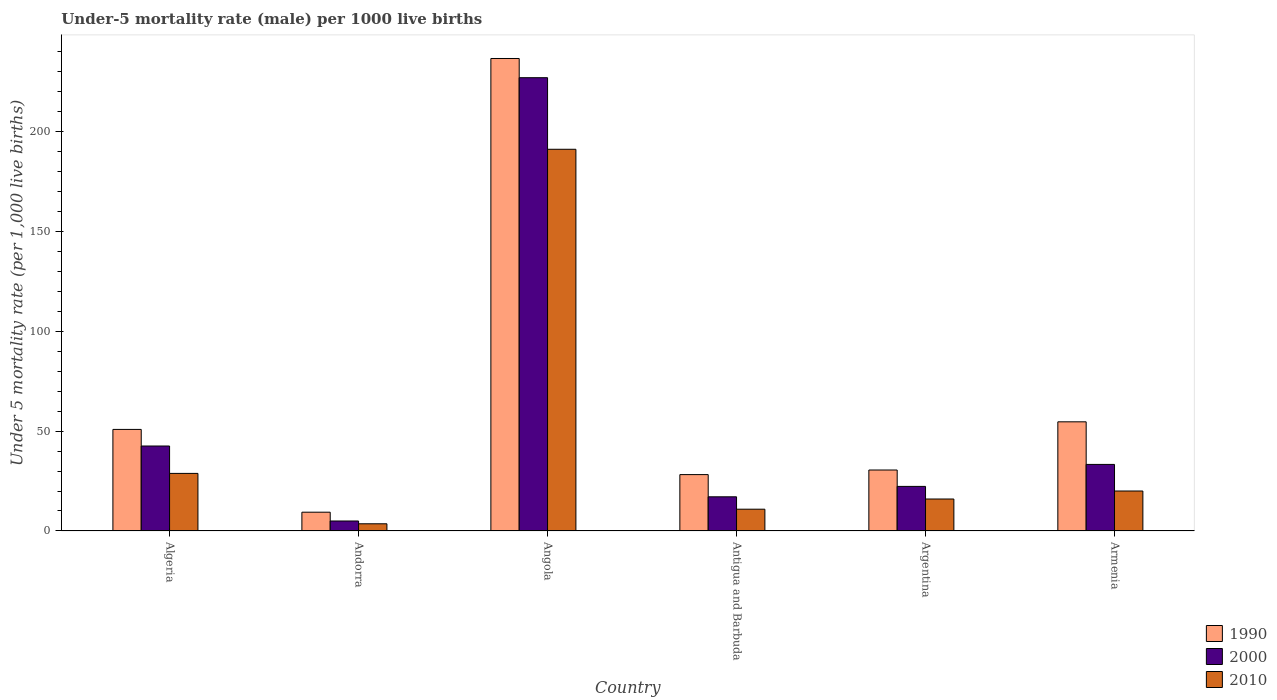How many groups of bars are there?
Provide a succinct answer. 6. Are the number of bars on each tick of the X-axis equal?
Keep it short and to the point. Yes. What is the label of the 1st group of bars from the left?
Ensure brevity in your answer.  Algeria. In how many cases, is the number of bars for a given country not equal to the number of legend labels?
Your answer should be compact. 0. What is the under-five mortality rate in 1990 in Andorra?
Offer a very short reply. 9.4. Across all countries, what is the maximum under-five mortality rate in 1990?
Your response must be concise. 236.3. Across all countries, what is the minimum under-five mortality rate in 2000?
Provide a succinct answer. 5. In which country was the under-five mortality rate in 1990 maximum?
Your response must be concise. Angola. In which country was the under-five mortality rate in 1990 minimum?
Your answer should be compact. Andorra. What is the total under-five mortality rate in 1990 in the graph?
Offer a terse response. 409.8. What is the difference between the under-five mortality rate in 1990 in Algeria and that in Argentina?
Your answer should be very brief. 20.3. What is the difference between the under-five mortality rate in 1990 in Algeria and the under-five mortality rate in 2010 in Andorra?
Ensure brevity in your answer.  47.2. What is the average under-five mortality rate in 2000 per country?
Your answer should be very brief. 57.82. In how many countries, is the under-five mortality rate in 1990 greater than 160?
Provide a short and direct response. 1. What is the ratio of the under-five mortality rate in 2010 in Algeria to that in Angola?
Provide a succinct answer. 0.15. What is the difference between the highest and the second highest under-five mortality rate in 2000?
Provide a succinct answer. -193.4. What is the difference between the highest and the lowest under-five mortality rate in 1990?
Keep it short and to the point. 226.9. Is the sum of the under-five mortality rate in 1990 in Angola and Argentina greater than the maximum under-five mortality rate in 2000 across all countries?
Offer a terse response. Yes. What does the 1st bar from the left in Antigua and Barbuda represents?
Your answer should be very brief. 1990. What does the 1st bar from the right in Andorra represents?
Your answer should be very brief. 2010. How many bars are there?
Offer a terse response. 18. Are all the bars in the graph horizontal?
Keep it short and to the point. No. What is the difference between two consecutive major ticks on the Y-axis?
Offer a very short reply. 50. Are the values on the major ticks of Y-axis written in scientific E-notation?
Provide a short and direct response. No. Does the graph contain grids?
Your response must be concise. No. Where does the legend appear in the graph?
Offer a terse response. Bottom right. How are the legend labels stacked?
Keep it short and to the point. Vertical. What is the title of the graph?
Offer a very short reply. Under-5 mortality rate (male) per 1000 live births. What is the label or title of the Y-axis?
Provide a succinct answer. Under 5 mortality rate (per 1,0 live births). What is the Under 5 mortality rate (per 1,000 live births) of 1990 in Algeria?
Offer a terse response. 50.8. What is the Under 5 mortality rate (per 1,000 live births) of 2000 in Algeria?
Provide a succinct answer. 42.5. What is the Under 5 mortality rate (per 1,000 live births) in 2010 in Algeria?
Ensure brevity in your answer.  28.8. What is the Under 5 mortality rate (per 1,000 live births) in 1990 in Andorra?
Your answer should be very brief. 9.4. What is the Under 5 mortality rate (per 1,000 live births) in 2000 in Andorra?
Offer a very short reply. 5. What is the Under 5 mortality rate (per 1,000 live births) of 1990 in Angola?
Your response must be concise. 236.3. What is the Under 5 mortality rate (per 1,000 live births) in 2000 in Angola?
Keep it short and to the point. 226.7. What is the Under 5 mortality rate (per 1,000 live births) in 2010 in Angola?
Make the answer very short. 190.9. What is the Under 5 mortality rate (per 1,000 live births) of 1990 in Antigua and Barbuda?
Give a very brief answer. 28.2. What is the Under 5 mortality rate (per 1,000 live births) of 2010 in Antigua and Barbuda?
Your answer should be very brief. 10.9. What is the Under 5 mortality rate (per 1,000 live births) of 1990 in Argentina?
Keep it short and to the point. 30.5. What is the Under 5 mortality rate (per 1,000 live births) in 2000 in Argentina?
Offer a terse response. 22.3. What is the Under 5 mortality rate (per 1,000 live births) of 1990 in Armenia?
Offer a terse response. 54.6. What is the Under 5 mortality rate (per 1,000 live births) in 2000 in Armenia?
Keep it short and to the point. 33.3. What is the Under 5 mortality rate (per 1,000 live births) in 2010 in Armenia?
Your response must be concise. 20. Across all countries, what is the maximum Under 5 mortality rate (per 1,000 live births) in 1990?
Your answer should be compact. 236.3. Across all countries, what is the maximum Under 5 mortality rate (per 1,000 live births) of 2000?
Your answer should be compact. 226.7. Across all countries, what is the maximum Under 5 mortality rate (per 1,000 live births) of 2010?
Offer a very short reply. 190.9. Across all countries, what is the minimum Under 5 mortality rate (per 1,000 live births) in 1990?
Ensure brevity in your answer.  9.4. What is the total Under 5 mortality rate (per 1,000 live births) in 1990 in the graph?
Ensure brevity in your answer.  409.8. What is the total Under 5 mortality rate (per 1,000 live births) in 2000 in the graph?
Ensure brevity in your answer.  346.9. What is the total Under 5 mortality rate (per 1,000 live births) of 2010 in the graph?
Ensure brevity in your answer.  270.2. What is the difference between the Under 5 mortality rate (per 1,000 live births) in 1990 in Algeria and that in Andorra?
Ensure brevity in your answer.  41.4. What is the difference between the Under 5 mortality rate (per 1,000 live births) in 2000 in Algeria and that in Andorra?
Offer a very short reply. 37.5. What is the difference between the Under 5 mortality rate (per 1,000 live births) in 2010 in Algeria and that in Andorra?
Ensure brevity in your answer.  25.2. What is the difference between the Under 5 mortality rate (per 1,000 live births) in 1990 in Algeria and that in Angola?
Your answer should be compact. -185.5. What is the difference between the Under 5 mortality rate (per 1,000 live births) in 2000 in Algeria and that in Angola?
Provide a succinct answer. -184.2. What is the difference between the Under 5 mortality rate (per 1,000 live births) in 2010 in Algeria and that in Angola?
Your answer should be compact. -162.1. What is the difference between the Under 5 mortality rate (per 1,000 live births) in 1990 in Algeria and that in Antigua and Barbuda?
Your answer should be compact. 22.6. What is the difference between the Under 5 mortality rate (per 1,000 live births) of 2000 in Algeria and that in Antigua and Barbuda?
Your answer should be compact. 25.4. What is the difference between the Under 5 mortality rate (per 1,000 live births) in 2010 in Algeria and that in Antigua and Barbuda?
Your answer should be compact. 17.9. What is the difference between the Under 5 mortality rate (per 1,000 live births) of 1990 in Algeria and that in Argentina?
Make the answer very short. 20.3. What is the difference between the Under 5 mortality rate (per 1,000 live births) of 2000 in Algeria and that in Argentina?
Ensure brevity in your answer.  20.2. What is the difference between the Under 5 mortality rate (per 1,000 live births) in 1990 in Algeria and that in Armenia?
Your answer should be compact. -3.8. What is the difference between the Under 5 mortality rate (per 1,000 live births) in 2000 in Algeria and that in Armenia?
Your answer should be very brief. 9.2. What is the difference between the Under 5 mortality rate (per 1,000 live births) in 2010 in Algeria and that in Armenia?
Your response must be concise. 8.8. What is the difference between the Under 5 mortality rate (per 1,000 live births) of 1990 in Andorra and that in Angola?
Provide a succinct answer. -226.9. What is the difference between the Under 5 mortality rate (per 1,000 live births) in 2000 in Andorra and that in Angola?
Ensure brevity in your answer.  -221.7. What is the difference between the Under 5 mortality rate (per 1,000 live births) in 2010 in Andorra and that in Angola?
Your response must be concise. -187.3. What is the difference between the Under 5 mortality rate (per 1,000 live births) in 1990 in Andorra and that in Antigua and Barbuda?
Your answer should be very brief. -18.8. What is the difference between the Under 5 mortality rate (per 1,000 live births) in 1990 in Andorra and that in Argentina?
Provide a succinct answer. -21.1. What is the difference between the Under 5 mortality rate (per 1,000 live births) in 2000 in Andorra and that in Argentina?
Your answer should be very brief. -17.3. What is the difference between the Under 5 mortality rate (per 1,000 live births) in 1990 in Andorra and that in Armenia?
Provide a succinct answer. -45.2. What is the difference between the Under 5 mortality rate (per 1,000 live births) of 2000 in Andorra and that in Armenia?
Offer a very short reply. -28.3. What is the difference between the Under 5 mortality rate (per 1,000 live births) in 2010 in Andorra and that in Armenia?
Make the answer very short. -16.4. What is the difference between the Under 5 mortality rate (per 1,000 live births) of 1990 in Angola and that in Antigua and Barbuda?
Make the answer very short. 208.1. What is the difference between the Under 5 mortality rate (per 1,000 live births) in 2000 in Angola and that in Antigua and Barbuda?
Provide a succinct answer. 209.6. What is the difference between the Under 5 mortality rate (per 1,000 live births) in 2010 in Angola and that in Antigua and Barbuda?
Ensure brevity in your answer.  180. What is the difference between the Under 5 mortality rate (per 1,000 live births) of 1990 in Angola and that in Argentina?
Your response must be concise. 205.8. What is the difference between the Under 5 mortality rate (per 1,000 live births) in 2000 in Angola and that in Argentina?
Offer a very short reply. 204.4. What is the difference between the Under 5 mortality rate (per 1,000 live births) of 2010 in Angola and that in Argentina?
Make the answer very short. 174.9. What is the difference between the Under 5 mortality rate (per 1,000 live births) in 1990 in Angola and that in Armenia?
Offer a terse response. 181.7. What is the difference between the Under 5 mortality rate (per 1,000 live births) of 2000 in Angola and that in Armenia?
Ensure brevity in your answer.  193.4. What is the difference between the Under 5 mortality rate (per 1,000 live births) in 2010 in Angola and that in Armenia?
Provide a succinct answer. 170.9. What is the difference between the Under 5 mortality rate (per 1,000 live births) in 1990 in Antigua and Barbuda and that in Argentina?
Give a very brief answer. -2.3. What is the difference between the Under 5 mortality rate (per 1,000 live births) of 1990 in Antigua and Barbuda and that in Armenia?
Provide a succinct answer. -26.4. What is the difference between the Under 5 mortality rate (per 1,000 live births) in 2000 in Antigua and Barbuda and that in Armenia?
Ensure brevity in your answer.  -16.2. What is the difference between the Under 5 mortality rate (per 1,000 live births) in 2010 in Antigua and Barbuda and that in Armenia?
Your answer should be compact. -9.1. What is the difference between the Under 5 mortality rate (per 1,000 live births) of 1990 in Argentina and that in Armenia?
Provide a succinct answer. -24.1. What is the difference between the Under 5 mortality rate (per 1,000 live births) in 2000 in Argentina and that in Armenia?
Your answer should be very brief. -11. What is the difference between the Under 5 mortality rate (per 1,000 live births) of 1990 in Algeria and the Under 5 mortality rate (per 1,000 live births) of 2000 in Andorra?
Make the answer very short. 45.8. What is the difference between the Under 5 mortality rate (per 1,000 live births) of 1990 in Algeria and the Under 5 mortality rate (per 1,000 live births) of 2010 in Andorra?
Your answer should be very brief. 47.2. What is the difference between the Under 5 mortality rate (per 1,000 live births) of 2000 in Algeria and the Under 5 mortality rate (per 1,000 live births) of 2010 in Andorra?
Offer a terse response. 38.9. What is the difference between the Under 5 mortality rate (per 1,000 live births) in 1990 in Algeria and the Under 5 mortality rate (per 1,000 live births) in 2000 in Angola?
Your answer should be very brief. -175.9. What is the difference between the Under 5 mortality rate (per 1,000 live births) in 1990 in Algeria and the Under 5 mortality rate (per 1,000 live births) in 2010 in Angola?
Offer a terse response. -140.1. What is the difference between the Under 5 mortality rate (per 1,000 live births) in 2000 in Algeria and the Under 5 mortality rate (per 1,000 live births) in 2010 in Angola?
Give a very brief answer. -148.4. What is the difference between the Under 5 mortality rate (per 1,000 live births) in 1990 in Algeria and the Under 5 mortality rate (per 1,000 live births) in 2000 in Antigua and Barbuda?
Ensure brevity in your answer.  33.7. What is the difference between the Under 5 mortality rate (per 1,000 live births) of 1990 in Algeria and the Under 5 mortality rate (per 1,000 live births) of 2010 in Antigua and Barbuda?
Offer a very short reply. 39.9. What is the difference between the Under 5 mortality rate (per 1,000 live births) in 2000 in Algeria and the Under 5 mortality rate (per 1,000 live births) in 2010 in Antigua and Barbuda?
Make the answer very short. 31.6. What is the difference between the Under 5 mortality rate (per 1,000 live births) in 1990 in Algeria and the Under 5 mortality rate (per 1,000 live births) in 2010 in Argentina?
Your response must be concise. 34.8. What is the difference between the Under 5 mortality rate (per 1,000 live births) of 2000 in Algeria and the Under 5 mortality rate (per 1,000 live births) of 2010 in Argentina?
Ensure brevity in your answer.  26.5. What is the difference between the Under 5 mortality rate (per 1,000 live births) of 1990 in Algeria and the Under 5 mortality rate (per 1,000 live births) of 2000 in Armenia?
Offer a very short reply. 17.5. What is the difference between the Under 5 mortality rate (per 1,000 live births) in 1990 in Algeria and the Under 5 mortality rate (per 1,000 live births) in 2010 in Armenia?
Provide a succinct answer. 30.8. What is the difference between the Under 5 mortality rate (per 1,000 live births) in 2000 in Algeria and the Under 5 mortality rate (per 1,000 live births) in 2010 in Armenia?
Offer a terse response. 22.5. What is the difference between the Under 5 mortality rate (per 1,000 live births) of 1990 in Andorra and the Under 5 mortality rate (per 1,000 live births) of 2000 in Angola?
Your response must be concise. -217.3. What is the difference between the Under 5 mortality rate (per 1,000 live births) in 1990 in Andorra and the Under 5 mortality rate (per 1,000 live births) in 2010 in Angola?
Provide a short and direct response. -181.5. What is the difference between the Under 5 mortality rate (per 1,000 live births) in 2000 in Andorra and the Under 5 mortality rate (per 1,000 live births) in 2010 in Angola?
Provide a succinct answer. -185.9. What is the difference between the Under 5 mortality rate (per 1,000 live births) in 1990 in Andorra and the Under 5 mortality rate (per 1,000 live births) in 2000 in Antigua and Barbuda?
Your answer should be compact. -7.7. What is the difference between the Under 5 mortality rate (per 1,000 live births) of 2000 in Andorra and the Under 5 mortality rate (per 1,000 live births) of 2010 in Antigua and Barbuda?
Provide a succinct answer. -5.9. What is the difference between the Under 5 mortality rate (per 1,000 live births) in 1990 in Andorra and the Under 5 mortality rate (per 1,000 live births) in 2010 in Argentina?
Make the answer very short. -6.6. What is the difference between the Under 5 mortality rate (per 1,000 live births) of 1990 in Andorra and the Under 5 mortality rate (per 1,000 live births) of 2000 in Armenia?
Your response must be concise. -23.9. What is the difference between the Under 5 mortality rate (per 1,000 live births) of 1990 in Andorra and the Under 5 mortality rate (per 1,000 live births) of 2010 in Armenia?
Give a very brief answer. -10.6. What is the difference between the Under 5 mortality rate (per 1,000 live births) of 1990 in Angola and the Under 5 mortality rate (per 1,000 live births) of 2000 in Antigua and Barbuda?
Keep it short and to the point. 219.2. What is the difference between the Under 5 mortality rate (per 1,000 live births) of 1990 in Angola and the Under 5 mortality rate (per 1,000 live births) of 2010 in Antigua and Barbuda?
Keep it short and to the point. 225.4. What is the difference between the Under 5 mortality rate (per 1,000 live births) in 2000 in Angola and the Under 5 mortality rate (per 1,000 live births) in 2010 in Antigua and Barbuda?
Offer a terse response. 215.8. What is the difference between the Under 5 mortality rate (per 1,000 live births) of 1990 in Angola and the Under 5 mortality rate (per 1,000 live births) of 2000 in Argentina?
Offer a very short reply. 214. What is the difference between the Under 5 mortality rate (per 1,000 live births) in 1990 in Angola and the Under 5 mortality rate (per 1,000 live births) in 2010 in Argentina?
Your answer should be compact. 220.3. What is the difference between the Under 5 mortality rate (per 1,000 live births) in 2000 in Angola and the Under 5 mortality rate (per 1,000 live births) in 2010 in Argentina?
Offer a terse response. 210.7. What is the difference between the Under 5 mortality rate (per 1,000 live births) of 1990 in Angola and the Under 5 mortality rate (per 1,000 live births) of 2000 in Armenia?
Offer a very short reply. 203. What is the difference between the Under 5 mortality rate (per 1,000 live births) in 1990 in Angola and the Under 5 mortality rate (per 1,000 live births) in 2010 in Armenia?
Your answer should be compact. 216.3. What is the difference between the Under 5 mortality rate (per 1,000 live births) of 2000 in Angola and the Under 5 mortality rate (per 1,000 live births) of 2010 in Armenia?
Provide a short and direct response. 206.7. What is the difference between the Under 5 mortality rate (per 1,000 live births) of 1990 in Antigua and Barbuda and the Under 5 mortality rate (per 1,000 live births) of 2000 in Argentina?
Offer a very short reply. 5.9. What is the difference between the Under 5 mortality rate (per 1,000 live births) of 1990 in Antigua and Barbuda and the Under 5 mortality rate (per 1,000 live births) of 2010 in Argentina?
Provide a short and direct response. 12.2. What is the difference between the Under 5 mortality rate (per 1,000 live births) of 2000 in Antigua and Barbuda and the Under 5 mortality rate (per 1,000 live births) of 2010 in Argentina?
Give a very brief answer. 1.1. What is the difference between the Under 5 mortality rate (per 1,000 live births) in 1990 in Antigua and Barbuda and the Under 5 mortality rate (per 1,000 live births) in 2000 in Armenia?
Give a very brief answer. -5.1. What is the difference between the Under 5 mortality rate (per 1,000 live births) of 2000 in Antigua and Barbuda and the Under 5 mortality rate (per 1,000 live births) of 2010 in Armenia?
Your answer should be compact. -2.9. What is the difference between the Under 5 mortality rate (per 1,000 live births) of 1990 in Argentina and the Under 5 mortality rate (per 1,000 live births) of 2000 in Armenia?
Make the answer very short. -2.8. What is the difference between the Under 5 mortality rate (per 1,000 live births) in 1990 in Argentina and the Under 5 mortality rate (per 1,000 live births) in 2010 in Armenia?
Your response must be concise. 10.5. What is the difference between the Under 5 mortality rate (per 1,000 live births) of 2000 in Argentina and the Under 5 mortality rate (per 1,000 live births) of 2010 in Armenia?
Ensure brevity in your answer.  2.3. What is the average Under 5 mortality rate (per 1,000 live births) of 1990 per country?
Give a very brief answer. 68.3. What is the average Under 5 mortality rate (per 1,000 live births) in 2000 per country?
Your answer should be compact. 57.82. What is the average Under 5 mortality rate (per 1,000 live births) of 2010 per country?
Your response must be concise. 45.03. What is the difference between the Under 5 mortality rate (per 1,000 live births) of 1990 and Under 5 mortality rate (per 1,000 live births) of 2010 in Andorra?
Your answer should be very brief. 5.8. What is the difference between the Under 5 mortality rate (per 1,000 live births) of 2000 and Under 5 mortality rate (per 1,000 live births) of 2010 in Andorra?
Make the answer very short. 1.4. What is the difference between the Under 5 mortality rate (per 1,000 live births) of 1990 and Under 5 mortality rate (per 1,000 live births) of 2010 in Angola?
Give a very brief answer. 45.4. What is the difference between the Under 5 mortality rate (per 1,000 live births) in 2000 and Under 5 mortality rate (per 1,000 live births) in 2010 in Angola?
Give a very brief answer. 35.8. What is the difference between the Under 5 mortality rate (per 1,000 live births) in 1990 and Under 5 mortality rate (per 1,000 live births) in 2000 in Antigua and Barbuda?
Provide a short and direct response. 11.1. What is the difference between the Under 5 mortality rate (per 1,000 live births) in 1990 and Under 5 mortality rate (per 1,000 live births) in 2010 in Antigua and Barbuda?
Keep it short and to the point. 17.3. What is the difference between the Under 5 mortality rate (per 1,000 live births) in 2000 and Under 5 mortality rate (per 1,000 live births) in 2010 in Antigua and Barbuda?
Your answer should be compact. 6.2. What is the difference between the Under 5 mortality rate (per 1,000 live births) of 1990 and Under 5 mortality rate (per 1,000 live births) of 2010 in Argentina?
Offer a very short reply. 14.5. What is the difference between the Under 5 mortality rate (per 1,000 live births) in 2000 and Under 5 mortality rate (per 1,000 live births) in 2010 in Argentina?
Offer a very short reply. 6.3. What is the difference between the Under 5 mortality rate (per 1,000 live births) of 1990 and Under 5 mortality rate (per 1,000 live births) of 2000 in Armenia?
Your answer should be very brief. 21.3. What is the difference between the Under 5 mortality rate (per 1,000 live births) of 1990 and Under 5 mortality rate (per 1,000 live births) of 2010 in Armenia?
Offer a terse response. 34.6. What is the ratio of the Under 5 mortality rate (per 1,000 live births) of 1990 in Algeria to that in Andorra?
Provide a short and direct response. 5.4. What is the ratio of the Under 5 mortality rate (per 1,000 live births) of 2000 in Algeria to that in Andorra?
Ensure brevity in your answer.  8.5. What is the ratio of the Under 5 mortality rate (per 1,000 live births) in 1990 in Algeria to that in Angola?
Ensure brevity in your answer.  0.21. What is the ratio of the Under 5 mortality rate (per 1,000 live births) in 2000 in Algeria to that in Angola?
Provide a succinct answer. 0.19. What is the ratio of the Under 5 mortality rate (per 1,000 live births) in 2010 in Algeria to that in Angola?
Provide a succinct answer. 0.15. What is the ratio of the Under 5 mortality rate (per 1,000 live births) of 1990 in Algeria to that in Antigua and Barbuda?
Keep it short and to the point. 1.8. What is the ratio of the Under 5 mortality rate (per 1,000 live births) in 2000 in Algeria to that in Antigua and Barbuda?
Provide a succinct answer. 2.49. What is the ratio of the Under 5 mortality rate (per 1,000 live births) in 2010 in Algeria to that in Antigua and Barbuda?
Provide a succinct answer. 2.64. What is the ratio of the Under 5 mortality rate (per 1,000 live births) of 1990 in Algeria to that in Argentina?
Offer a very short reply. 1.67. What is the ratio of the Under 5 mortality rate (per 1,000 live births) in 2000 in Algeria to that in Argentina?
Make the answer very short. 1.91. What is the ratio of the Under 5 mortality rate (per 1,000 live births) in 1990 in Algeria to that in Armenia?
Keep it short and to the point. 0.93. What is the ratio of the Under 5 mortality rate (per 1,000 live births) in 2000 in Algeria to that in Armenia?
Provide a succinct answer. 1.28. What is the ratio of the Under 5 mortality rate (per 1,000 live births) of 2010 in Algeria to that in Armenia?
Make the answer very short. 1.44. What is the ratio of the Under 5 mortality rate (per 1,000 live births) in 1990 in Andorra to that in Angola?
Make the answer very short. 0.04. What is the ratio of the Under 5 mortality rate (per 1,000 live births) of 2000 in Andorra to that in Angola?
Your answer should be very brief. 0.02. What is the ratio of the Under 5 mortality rate (per 1,000 live births) of 2010 in Andorra to that in Angola?
Ensure brevity in your answer.  0.02. What is the ratio of the Under 5 mortality rate (per 1,000 live births) in 2000 in Andorra to that in Antigua and Barbuda?
Your response must be concise. 0.29. What is the ratio of the Under 5 mortality rate (per 1,000 live births) of 2010 in Andorra to that in Antigua and Barbuda?
Provide a short and direct response. 0.33. What is the ratio of the Under 5 mortality rate (per 1,000 live births) of 1990 in Andorra to that in Argentina?
Give a very brief answer. 0.31. What is the ratio of the Under 5 mortality rate (per 1,000 live births) of 2000 in Andorra to that in Argentina?
Your answer should be compact. 0.22. What is the ratio of the Under 5 mortality rate (per 1,000 live births) in 2010 in Andorra to that in Argentina?
Your answer should be compact. 0.23. What is the ratio of the Under 5 mortality rate (per 1,000 live births) of 1990 in Andorra to that in Armenia?
Make the answer very short. 0.17. What is the ratio of the Under 5 mortality rate (per 1,000 live births) of 2000 in Andorra to that in Armenia?
Give a very brief answer. 0.15. What is the ratio of the Under 5 mortality rate (per 1,000 live births) in 2010 in Andorra to that in Armenia?
Your answer should be compact. 0.18. What is the ratio of the Under 5 mortality rate (per 1,000 live births) in 1990 in Angola to that in Antigua and Barbuda?
Your answer should be very brief. 8.38. What is the ratio of the Under 5 mortality rate (per 1,000 live births) of 2000 in Angola to that in Antigua and Barbuda?
Your answer should be compact. 13.26. What is the ratio of the Under 5 mortality rate (per 1,000 live births) of 2010 in Angola to that in Antigua and Barbuda?
Provide a succinct answer. 17.51. What is the ratio of the Under 5 mortality rate (per 1,000 live births) of 1990 in Angola to that in Argentina?
Your answer should be very brief. 7.75. What is the ratio of the Under 5 mortality rate (per 1,000 live births) in 2000 in Angola to that in Argentina?
Ensure brevity in your answer.  10.17. What is the ratio of the Under 5 mortality rate (per 1,000 live births) of 2010 in Angola to that in Argentina?
Your answer should be compact. 11.93. What is the ratio of the Under 5 mortality rate (per 1,000 live births) in 1990 in Angola to that in Armenia?
Make the answer very short. 4.33. What is the ratio of the Under 5 mortality rate (per 1,000 live births) of 2000 in Angola to that in Armenia?
Your answer should be very brief. 6.81. What is the ratio of the Under 5 mortality rate (per 1,000 live births) of 2010 in Angola to that in Armenia?
Provide a succinct answer. 9.54. What is the ratio of the Under 5 mortality rate (per 1,000 live births) in 1990 in Antigua and Barbuda to that in Argentina?
Offer a very short reply. 0.92. What is the ratio of the Under 5 mortality rate (per 1,000 live births) in 2000 in Antigua and Barbuda to that in Argentina?
Your answer should be compact. 0.77. What is the ratio of the Under 5 mortality rate (per 1,000 live births) of 2010 in Antigua and Barbuda to that in Argentina?
Keep it short and to the point. 0.68. What is the ratio of the Under 5 mortality rate (per 1,000 live births) in 1990 in Antigua and Barbuda to that in Armenia?
Keep it short and to the point. 0.52. What is the ratio of the Under 5 mortality rate (per 1,000 live births) of 2000 in Antigua and Barbuda to that in Armenia?
Provide a short and direct response. 0.51. What is the ratio of the Under 5 mortality rate (per 1,000 live births) in 2010 in Antigua and Barbuda to that in Armenia?
Give a very brief answer. 0.55. What is the ratio of the Under 5 mortality rate (per 1,000 live births) of 1990 in Argentina to that in Armenia?
Keep it short and to the point. 0.56. What is the ratio of the Under 5 mortality rate (per 1,000 live births) in 2000 in Argentina to that in Armenia?
Ensure brevity in your answer.  0.67. What is the ratio of the Under 5 mortality rate (per 1,000 live births) of 2010 in Argentina to that in Armenia?
Ensure brevity in your answer.  0.8. What is the difference between the highest and the second highest Under 5 mortality rate (per 1,000 live births) in 1990?
Provide a short and direct response. 181.7. What is the difference between the highest and the second highest Under 5 mortality rate (per 1,000 live births) in 2000?
Offer a very short reply. 184.2. What is the difference between the highest and the second highest Under 5 mortality rate (per 1,000 live births) of 2010?
Make the answer very short. 162.1. What is the difference between the highest and the lowest Under 5 mortality rate (per 1,000 live births) of 1990?
Your answer should be compact. 226.9. What is the difference between the highest and the lowest Under 5 mortality rate (per 1,000 live births) of 2000?
Your answer should be compact. 221.7. What is the difference between the highest and the lowest Under 5 mortality rate (per 1,000 live births) in 2010?
Ensure brevity in your answer.  187.3. 